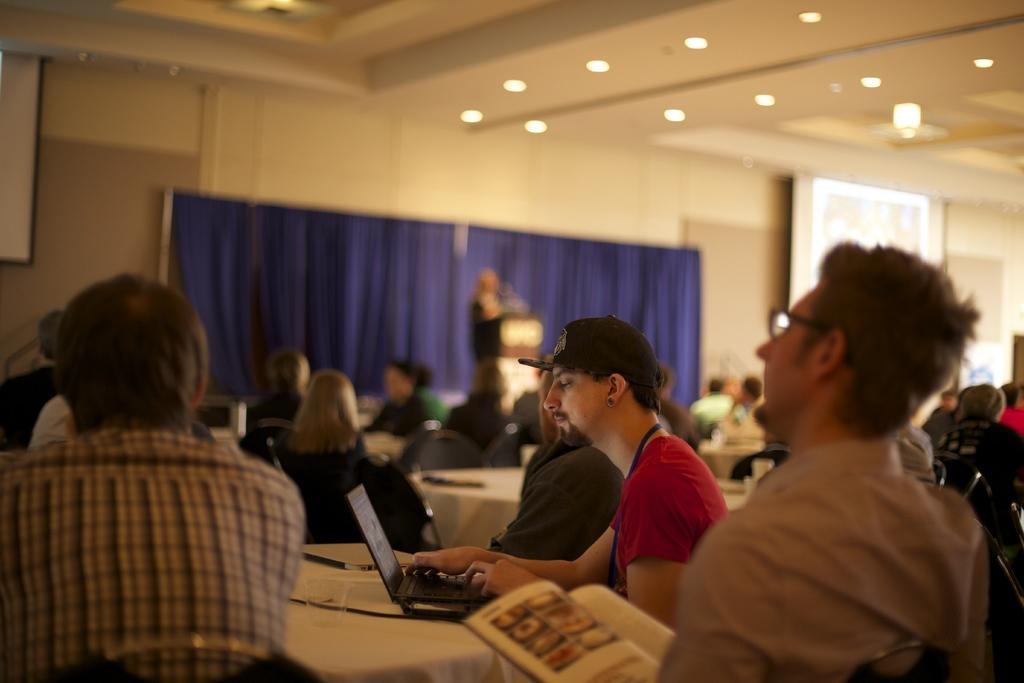How would you summarize this image in a sentence or two? In this image I can see a group of people are sitting on the chairs in front of tables on which I can see laptops, books, papers, mobiles and so on. In the background I can see a wall, screens, curtain and lights on a rooftop. This image is taken may be in a hall. 